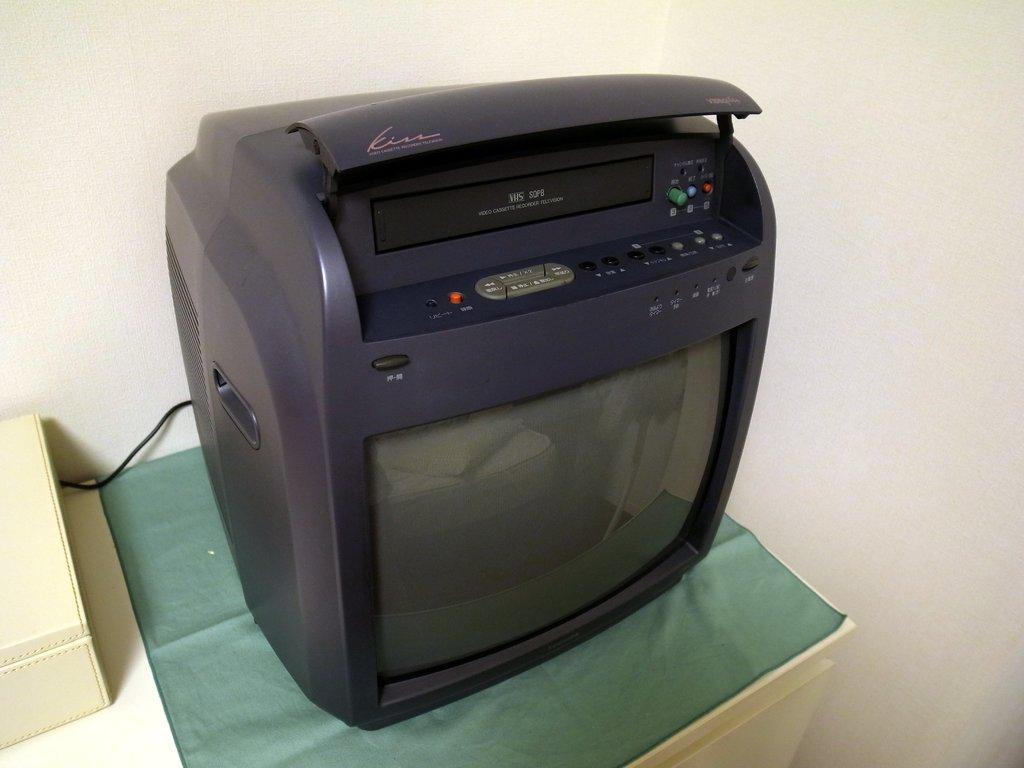How would you summarize this image in a sentence or two? In this picture we can see a Television on a green cloth. We can see this Television is on a white desk. There are reflections of a few objects on this Television. A white object is visible on the left side. 